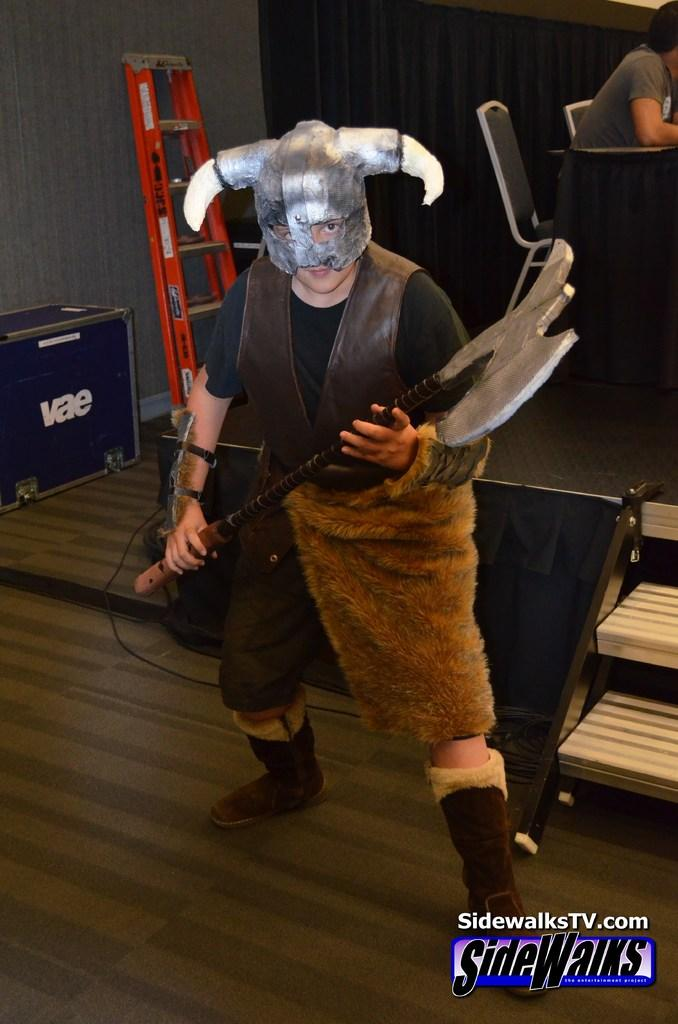What is the person in the image holding? The person is holding an equipment in the image. Where is the equipment located when not being held? The equipment is visible on the floor when not being held. What is the position of the person sitting in the image? The person sitting on a chair in the image. What is in front of the person sitting on the chair? The person sitting on the chair is in front of a table. Can you describe any other objects visible in the image? There are other objects visible in the image, but their specific details are not mentioned in the provided facts. What type of muscle is the cat flexing in the image? There is no cat present in the image, so it is not possible to answer a question about a cat's muscle. How many donkeys are visible in the image? There are no donkeys present in the image. 